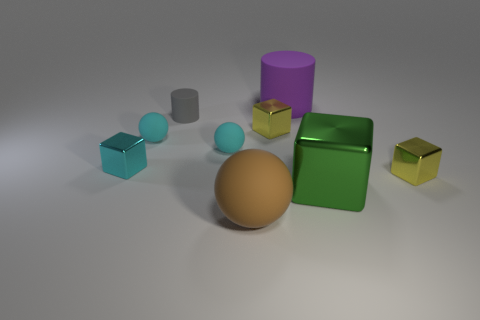Can you tell a story that could be based on the arrangement or colors of the objects? Certainly! In a tranquil corner of the geometric universe, the colorful entities live in harmony. The blue cube is the keeper of knowledge, the spheres are the wandering nomads, the green metal block is the guardian of the realm, and the cylinders are the ancient pillars of wisdom. Each color not only represents their role but also their unique energy that they bring to the balance of this vibrant world. 